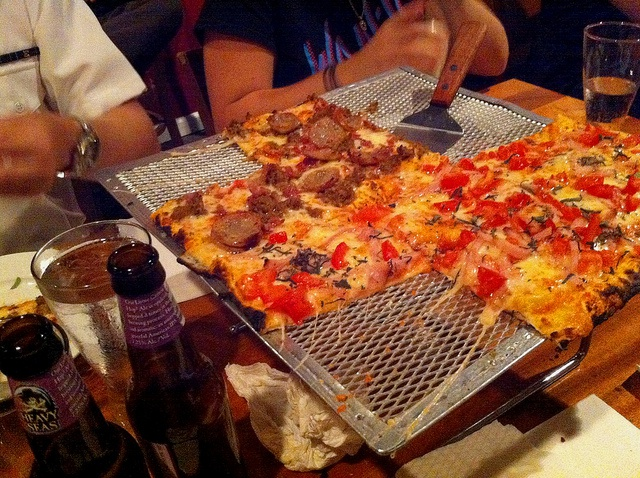Describe the objects in this image and their specific colors. I can see dining table in tan, black, maroon, brown, and red tones, pizza in tan, red, brown, and orange tones, people in tan, maroon, and brown tones, people in tan, black, brown, and maroon tones, and pizza in tan, red, orange, and brown tones in this image. 